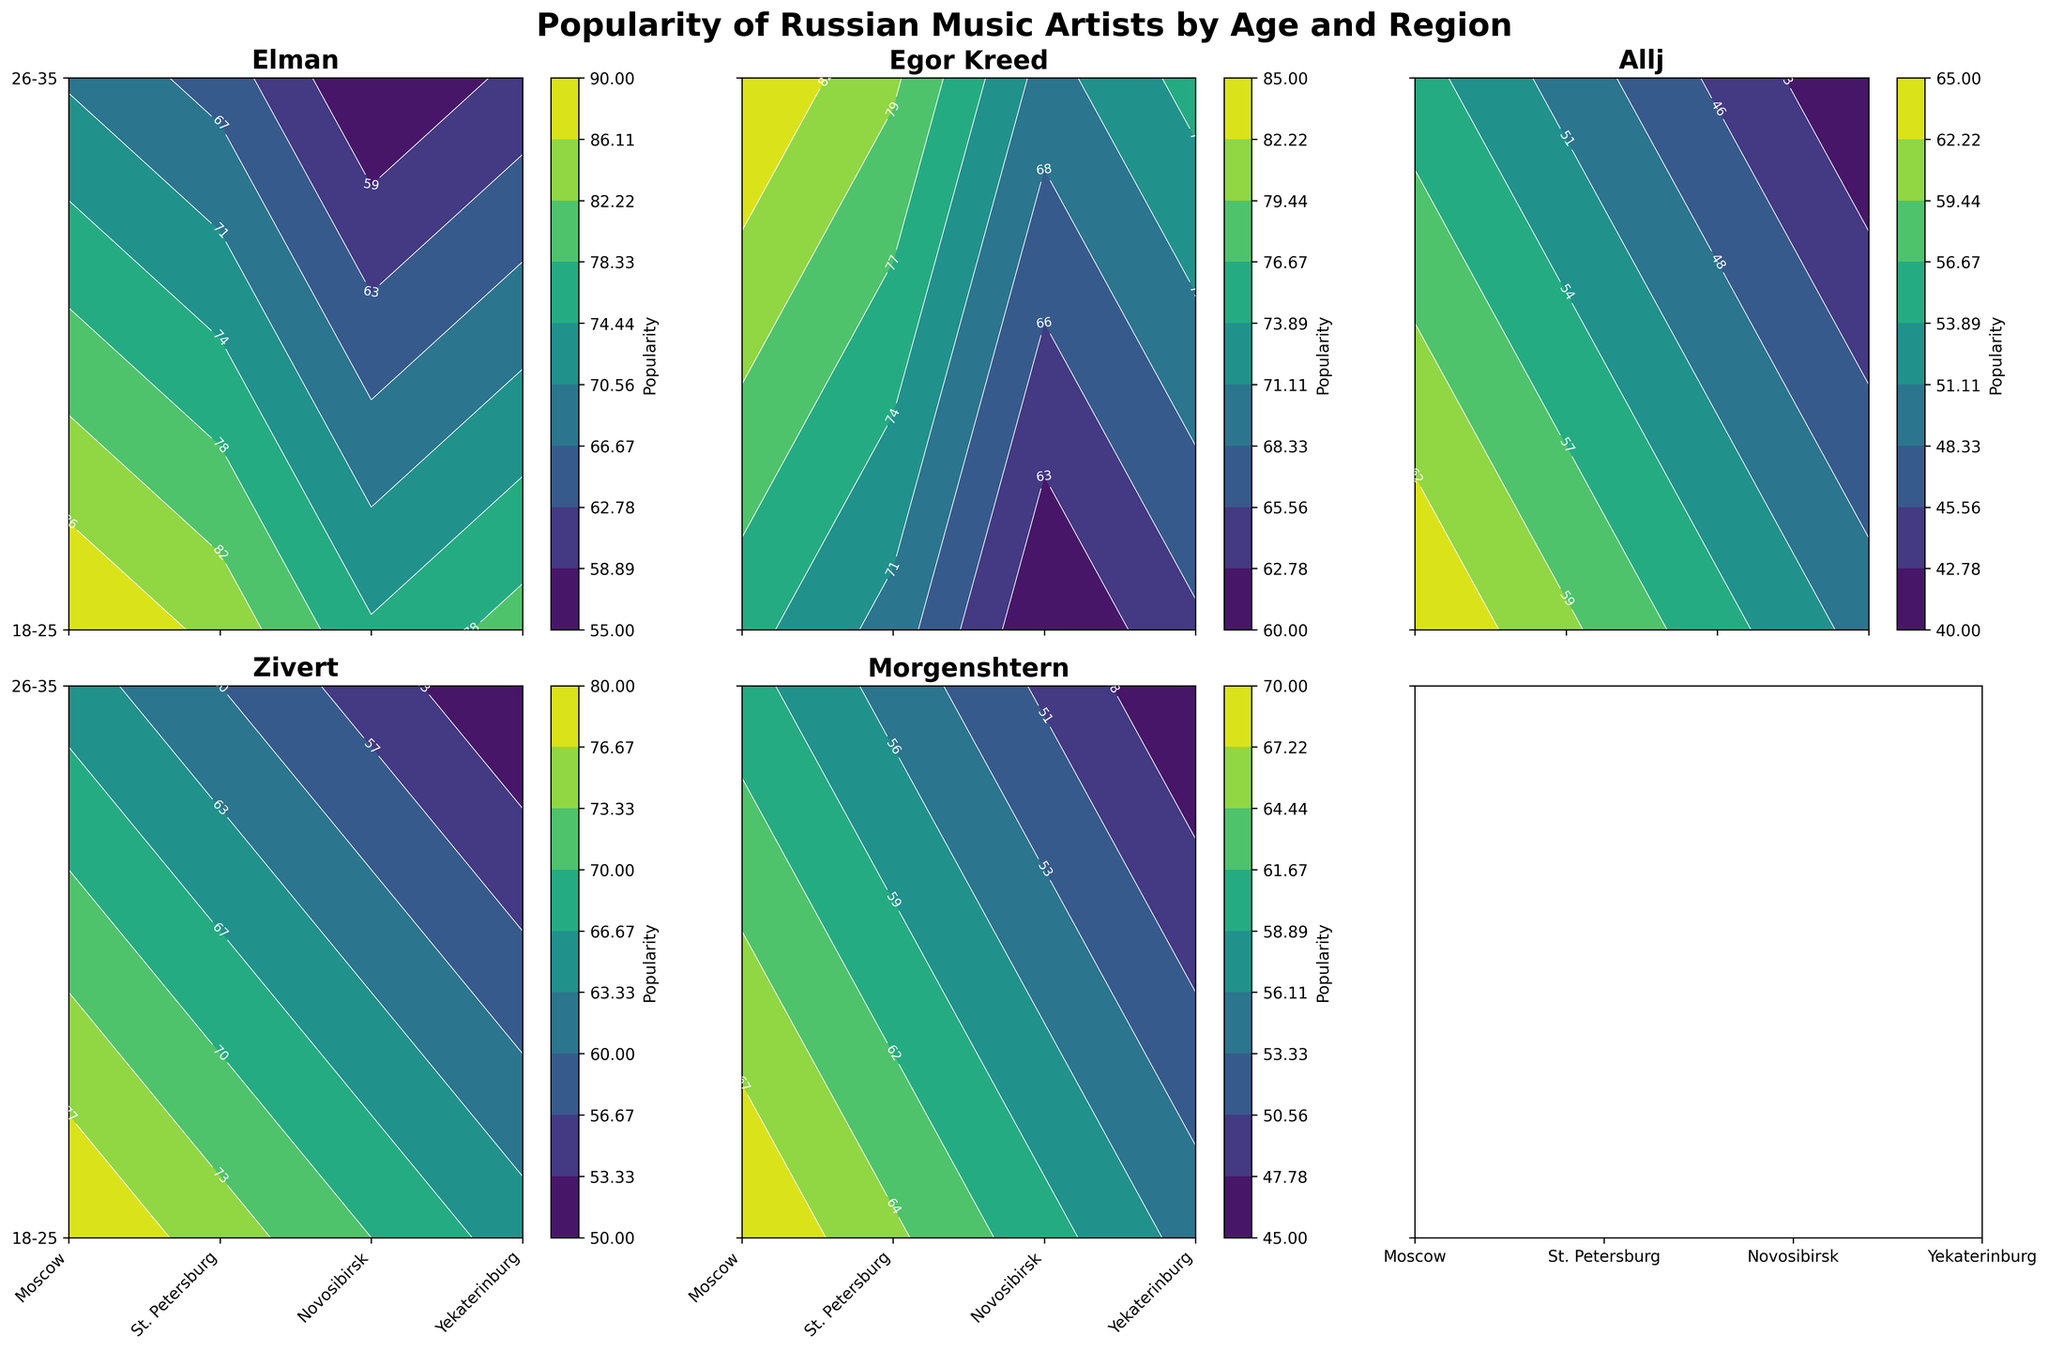How many regions are represented in the plot? Each subplot contains an x-axis with tick labels representing the regions. You can count these labels to find the number of regions. There are four regions: Moscow, St. Petersburg, Novosibirsk, and Yekaterinburg.
Answer: 4 Which artist has the highest popularity among the 18-25 age group in Moscow? Look at the titles of the subplots and check the contour levels for the 18-25 age group on the y-axis intersecting with Moscow on the x-axis. The highest contour value will indicate the most popular artist. Elman has a popularity of 90.
Answer: Elman In which city is Egor Kreed most popular among the 26-35 age group? Check the subplot titled "Egor Kreed" and look at the contour levels for the 26-35 age group on the y-axis. The highest contour value among these regions will indicate the city. The highest popularity is in Moscow with 85.
Answer: Moscow What's the difference in popularity of Morgenshtern between the 18-25 and 26-35 age groups in St. Petersburg? Locate the subplot for Morgenshtern and compare the contour levels for the 18-25 and 26-35 age groups in St. Petersburg. For the 18-25 age group, it's 65, and for the 26-35 age group, it's 55. The difference is 65 - 55.
Answer: 10 Between Allj and Zivert, who is more popular among 18-25 years old in Novosibirsk? Compare the contour levels for the 18-25 age group in the subplots for Allj and Zivert at Novosibirsk on the x-axis. Allj has 55, and Zivert has 70. Zivert is more popular.
Answer: Zivert What is the average popularity of Elman across all regions for the 26-35 age group? Check the subplot for Elman and sum the contour values for 26-35 in all regions, then divide by the number of regions. The values are 70 (Moscow), 65 (St. Petersburg), 55 (Novosibirsk), 60 (Yekaterinburg). Average is (70 + 65 + 55 + 60) / 4.
Answer: 62.5 Which artist has the least variance in popularity across all regions and age groups? Look at each artist's subplot and visually assess the contour consistency across all regions and age groups. Elman's plot shows more consistent contour levels compared to others.
Answer: Elman 